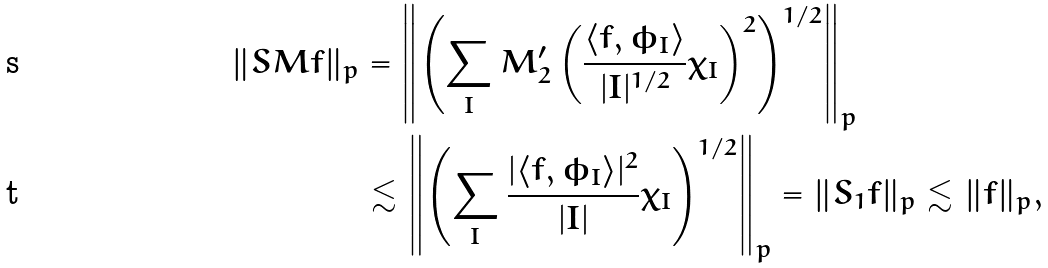<formula> <loc_0><loc_0><loc_500><loc_500>\| S M f \| _ { p } & = \left \| \left ( \sum _ { I } M _ { 2 } ^ { \prime } \left ( \frac { \langle f , \phi _ { I } \rangle } { | I | ^ { 1 / 2 } } \chi _ { I } \right ) ^ { 2 } \right ) ^ { 1 / 2 } \right \| _ { p } \\ & \lesssim \left \| \left ( \sum _ { I } \frac { | \langle f , \phi _ { I } \rangle | ^ { 2 } } { | I | } \chi _ { I } \right ) ^ { 1 / 2 } \right \| _ { p } = \| S _ { 1 } f \| _ { p } \lesssim \| f \| _ { p } ,</formula> 